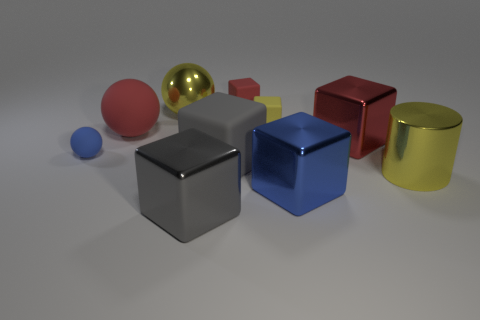Subtract all large blue metallic blocks. How many blocks are left? 5 Subtract all brown cylinders. How many red cubes are left? 2 Subtract all yellow cubes. How many cubes are left? 5 Subtract all blocks. How many objects are left? 4 Subtract all red blocks. Subtract all blue balls. How many blocks are left? 4 Subtract all gray matte cylinders. Subtract all big metallic cubes. How many objects are left? 7 Add 3 large cubes. How many large cubes are left? 7 Add 2 big red spheres. How many big red spheres exist? 3 Subtract 0 brown cylinders. How many objects are left? 10 